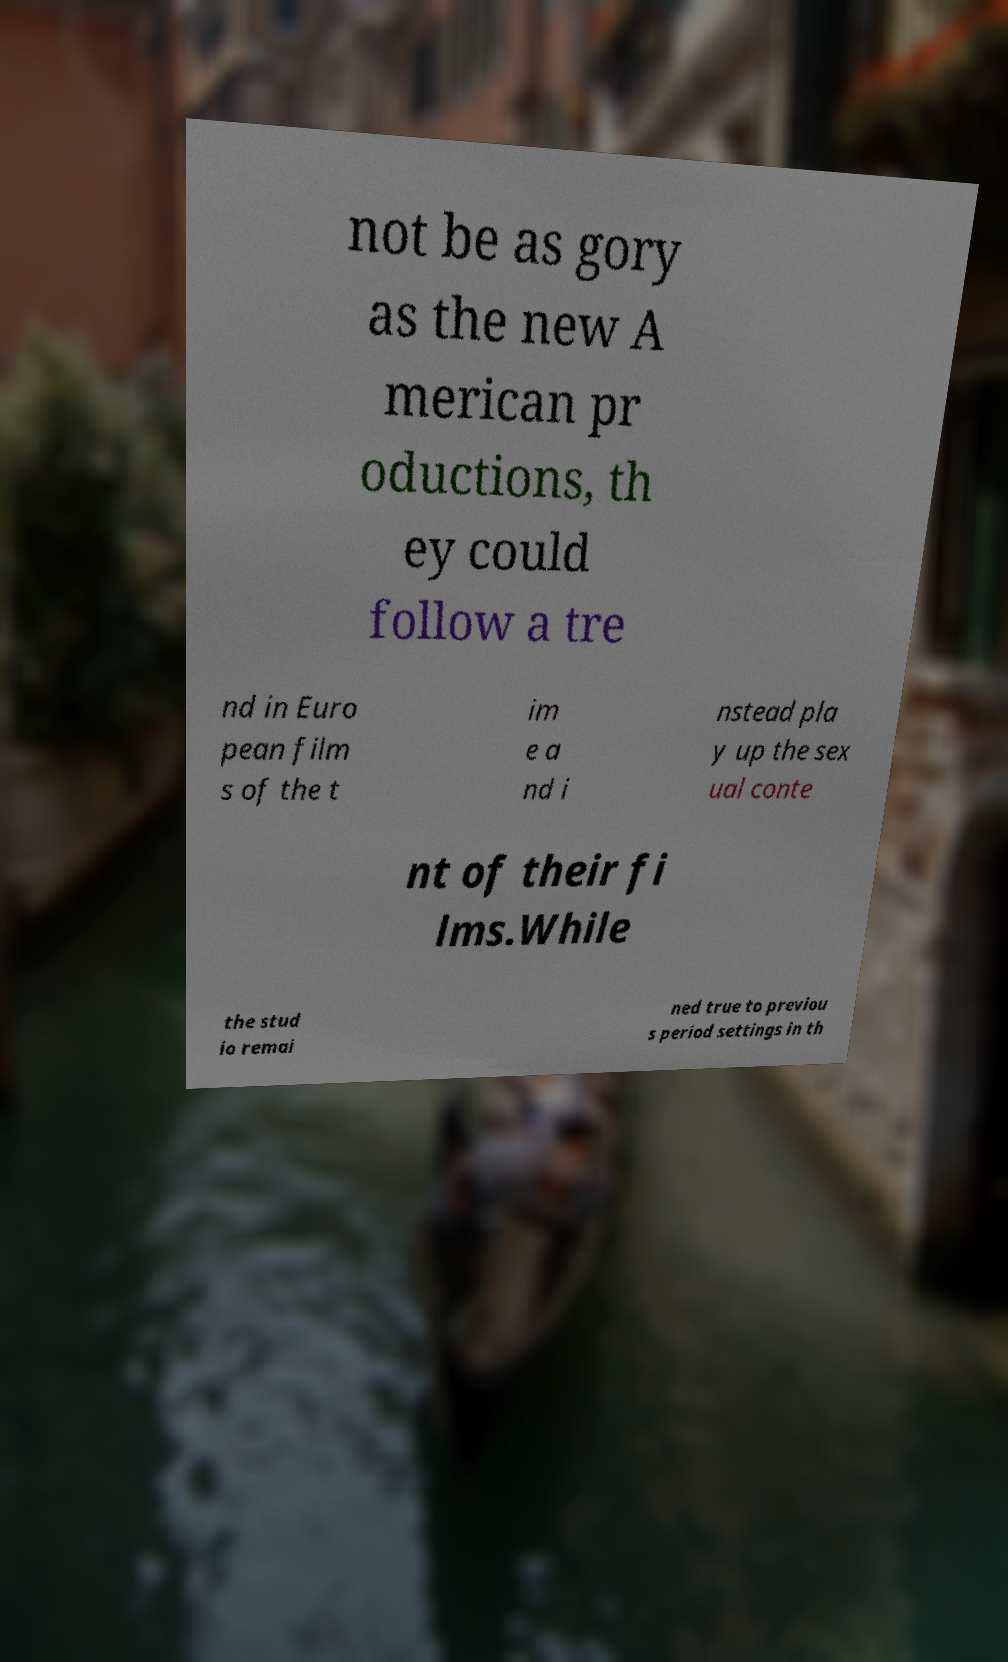I need the written content from this picture converted into text. Can you do that? not be as gory as the new A merican pr oductions, th ey could follow a tre nd in Euro pean film s of the t im e a nd i nstead pla y up the sex ual conte nt of their fi lms.While the stud io remai ned true to previou s period settings in th 